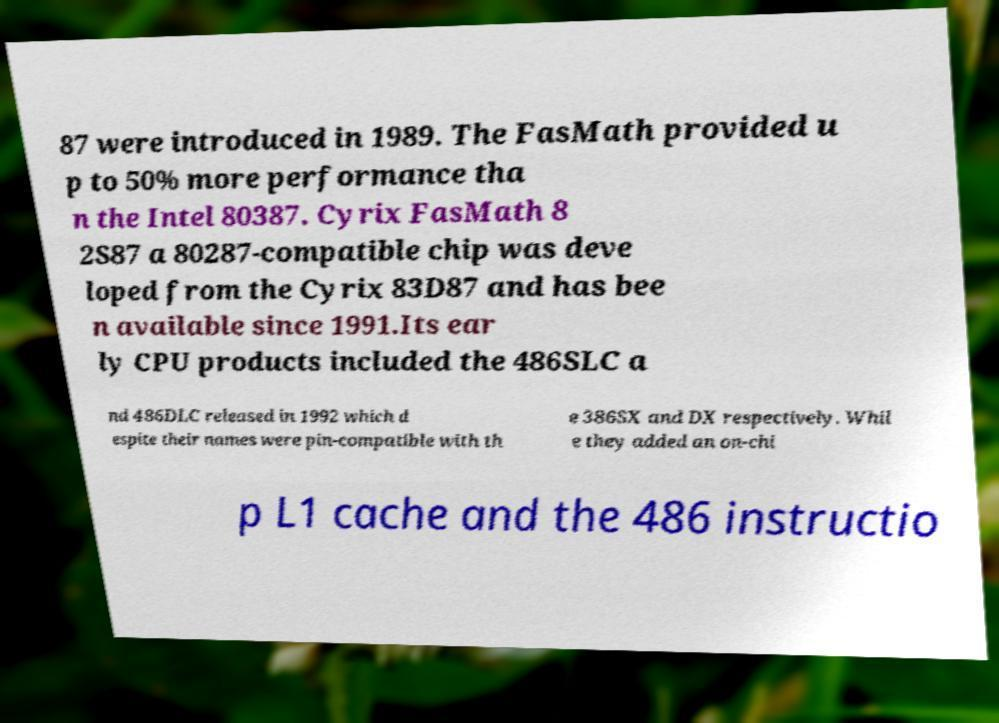Please identify and transcribe the text found in this image. 87 were introduced in 1989. The FasMath provided u p to 50% more performance tha n the Intel 80387. Cyrix FasMath 8 2S87 a 80287-compatible chip was deve loped from the Cyrix 83D87 and has bee n available since 1991.Its ear ly CPU products included the 486SLC a nd 486DLC released in 1992 which d espite their names were pin-compatible with th e 386SX and DX respectively. Whil e they added an on-chi p L1 cache and the 486 instructio 